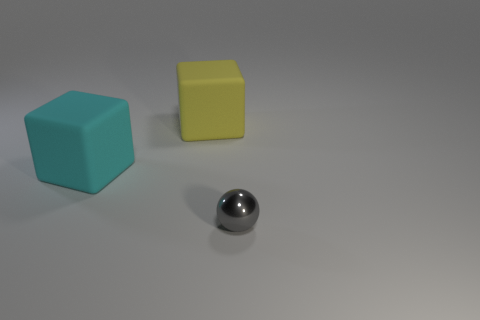Add 3 tiny blue rubber cylinders. How many objects exist? 6 Subtract all blocks. How many objects are left? 1 Add 3 tiny gray objects. How many tiny gray objects exist? 4 Subtract 0 brown spheres. How many objects are left? 3 Subtract all yellow cubes. Subtract all large matte objects. How many objects are left? 0 Add 1 yellow matte things. How many yellow matte things are left? 2 